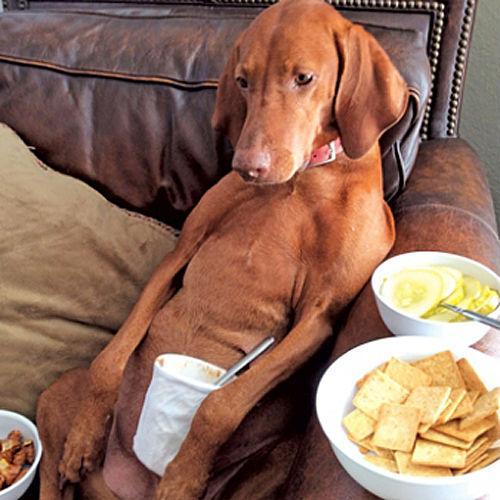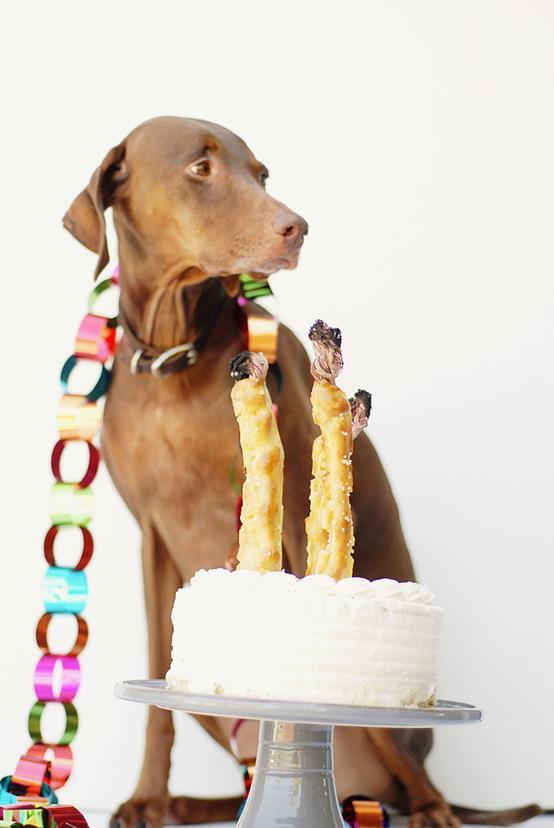The first image is the image on the left, the second image is the image on the right. Analyze the images presented: Is the assertion "At least one of the images has a cake in front of the dog." valid? Answer yes or no. Yes. The first image is the image on the left, the second image is the image on the right. Analyze the images presented: Is the assertion "Happy dogs weaing purple party hats with chin straps stare forward." valid? Answer yes or no. No. 